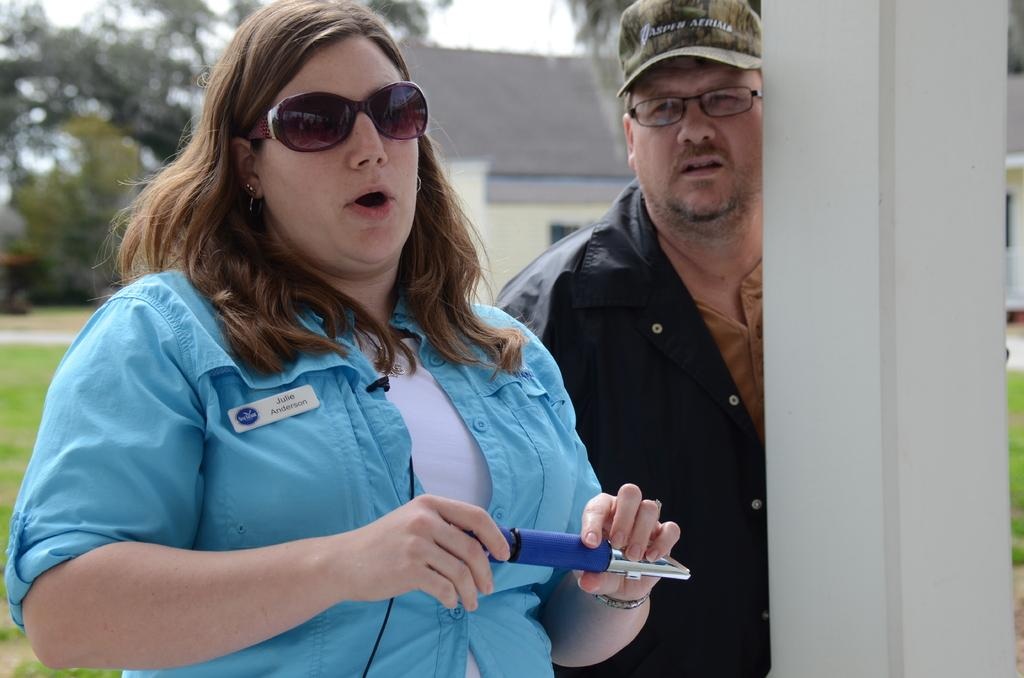How many people are present in the image? There is a man and a woman present in the image. What is the woman holding in her hands? The woman is holding an object in her hands. What can be seen in the background of the image? There is a house, trees, and the sky visible in the background of the image. How is the background of the image depicted? The background of the image is blurred. What type of story is being told by the waves in the image? There are no waves present in the image, so no story can be told by them. 